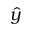Convert formula to latex. <formula><loc_0><loc_0><loc_500><loc_500>\hat { y }</formula> 